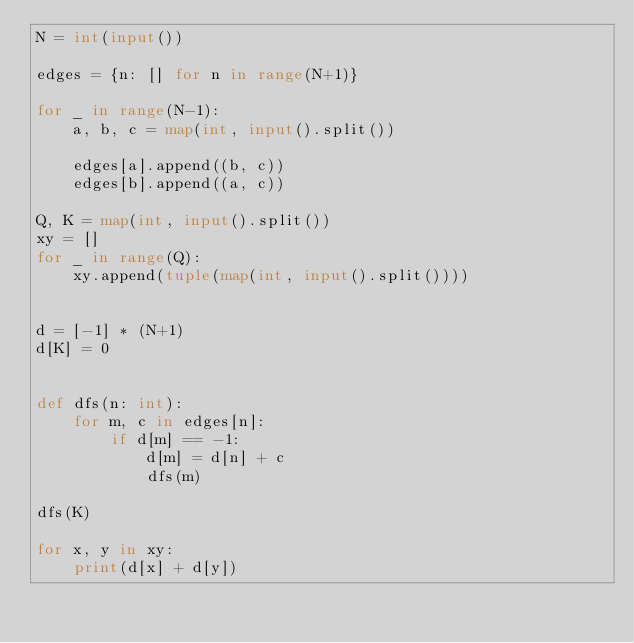<code> <loc_0><loc_0><loc_500><loc_500><_Python_>N = int(input())

edges = {n: [] for n in range(N+1)}

for _ in range(N-1):
    a, b, c = map(int, input().split())

    edges[a].append((b, c))
    edges[b].append((a, c))

Q, K = map(int, input().split())
xy = []
for _ in range(Q):
    xy.append(tuple(map(int, input().split())))


d = [-1] * (N+1)
d[K] = 0


def dfs(n: int):
    for m, c in edges[n]:
        if d[m] == -1:
            d[m] = d[n] + c
            dfs(m)

dfs(K)

for x, y in xy:
    print(d[x] + d[y])
</code> 